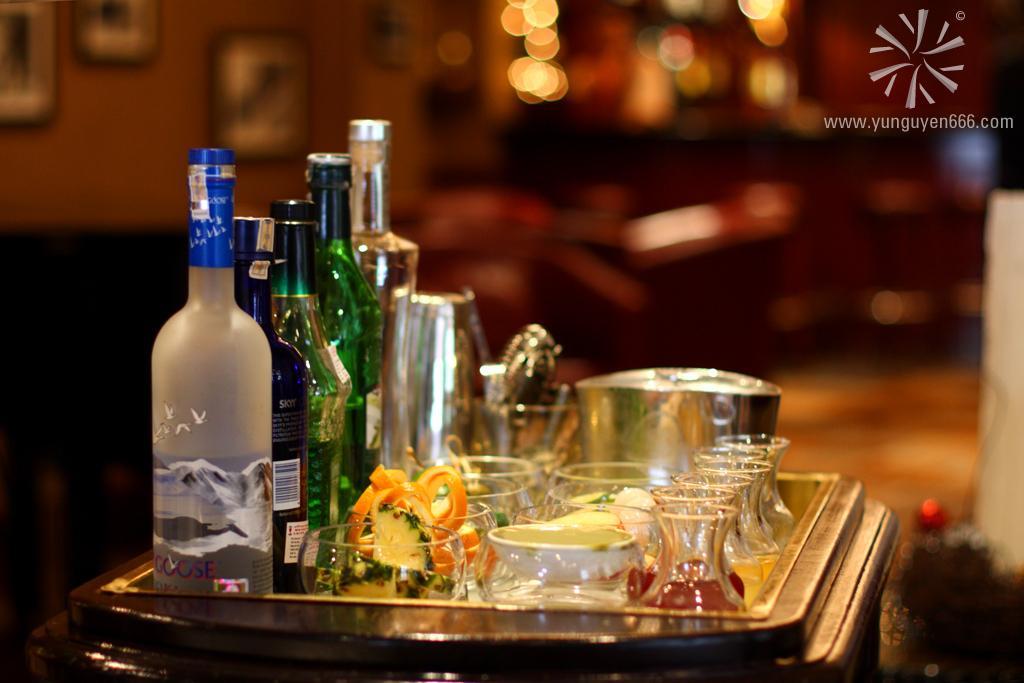Could you give a brief overview of what you see in this image? In this picture i could see some bottles with the lid on. Beside the bottles there are some bowls and in the bowls some fruits are arranged in it and there are some small glasses in which there are drinks, there is steel bowl also beside this bowls and they all are arranged on the small dining table which is brown in color. 